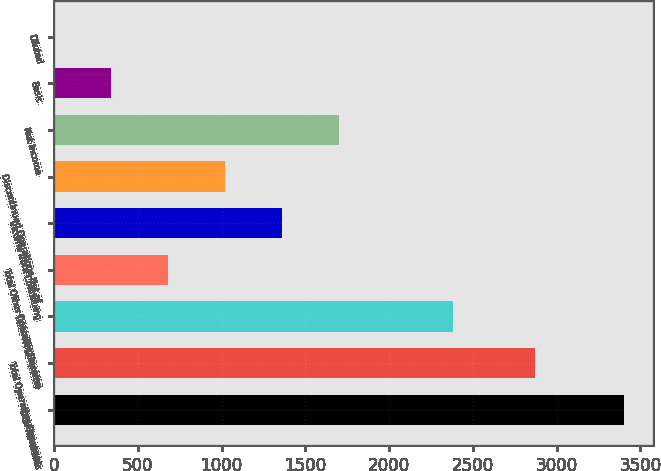Convert chart. <chart><loc_0><loc_0><loc_500><loc_500><bar_chart><fcel>Total Revenues<fcel>Total Operating Expenses<fcel>Operating Income<fcel>Total Other (Income) Expense<fcel>Income from Continuing<fcel>Discontinued Operations Net of<fcel>Net Income<fcel>Basic<fcel>Diluted<nl><fcel>3404<fcel>2870<fcel>2383.5<fcel>682.65<fcel>1362.99<fcel>1022.82<fcel>1703.16<fcel>342.48<fcel>2.31<nl></chart> 